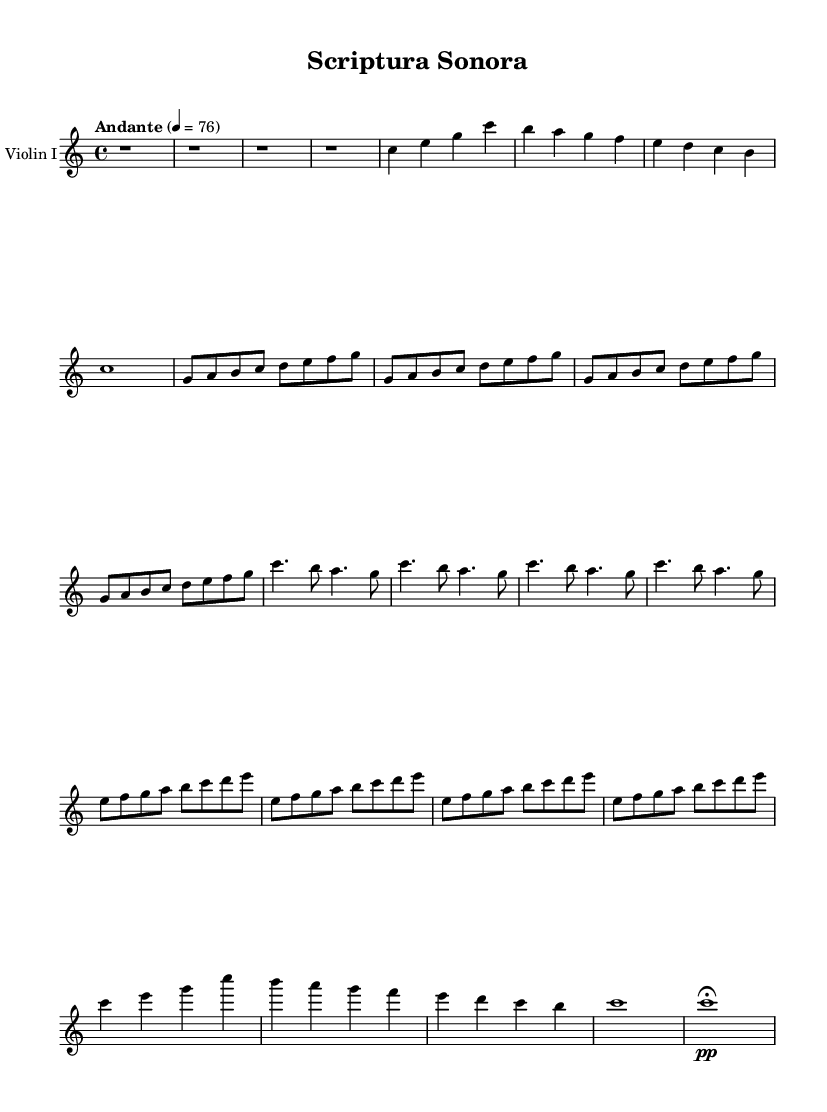What is the key signature of this music? The key signature is C major, which has no sharps or flats.
Answer: C major What is the time signature of the piece? The time signature is indicated at the beginning of the score, showing that there are four beats in a measure.
Answer: 4/4 What is the tempo marking of this symphony? The tempo marking provided in the score indicates a moderate pace, defined using the term "Andante" and a metronome marking of 76 quarter notes per minute.
Answer: Andante How many distinct themes are present in this composition? The score includes three distinct themes, each representing different writing systems: Latin Alphabet, Chinese Characters, and Arabic Script.
Answer: Three Describe the rhythmic structure of Theme C. The rhythmic structure features a combination of dotted quarter notes and eighth notes, creating a syncopated feel over the four repetitions.
Answer: Dotted quarter and eighth notes What section of the symphony follows the introduction? The section immediately following the introduction is Theme A, which explores the Latin Alphabet through melodic motifs.
Answer: Theme A In what section does the development occur, and how is it characterized? The development section occurs after Theme B and is characterized by a reference to a sequence of ascending notes that progress through the scale.
Answer: Development 